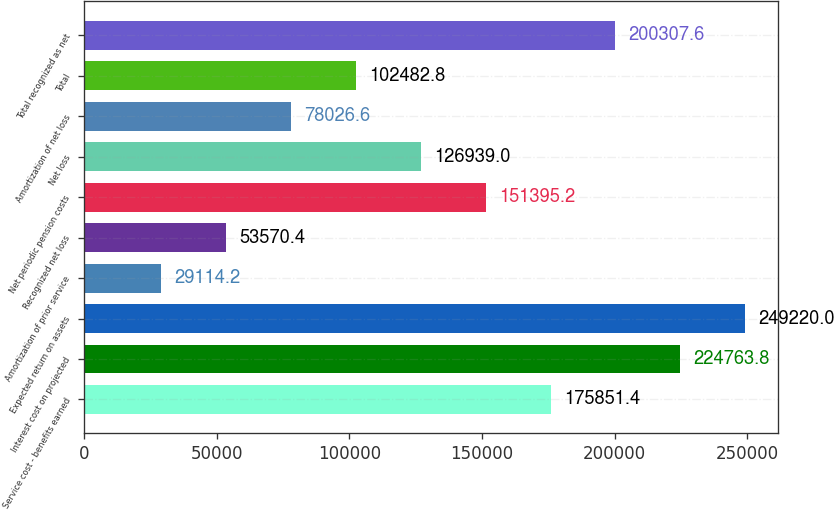Convert chart. <chart><loc_0><loc_0><loc_500><loc_500><bar_chart><fcel>Service cost - benefits earned<fcel>Interest cost on projected<fcel>Expected return on assets<fcel>Amortization of prior service<fcel>Recognized net loss<fcel>Net periodic pension costs<fcel>Net loss<fcel>Amortization of net loss<fcel>Total<fcel>Total recognized as net<nl><fcel>175851<fcel>224764<fcel>249220<fcel>29114.2<fcel>53570.4<fcel>151395<fcel>126939<fcel>78026.6<fcel>102483<fcel>200308<nl></chart> 